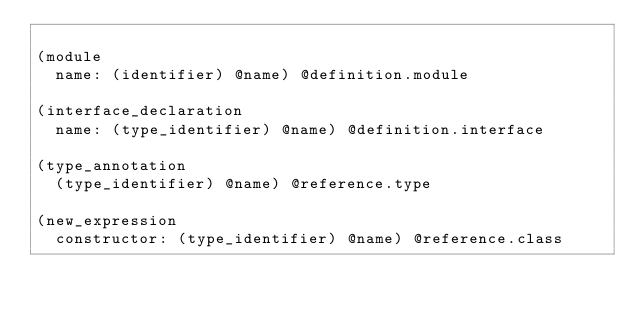<code> <loc_0><loc_0><loc_500><loc_500><_Scheme_>
(module
  name: (identifier) @name) @definition.module

(interface_declaration
  name: (type_identifier) @name) @definition.interface

(type_annotation
  (type_identifier) @name) @reference.type

(new_expression
  constructor: (type_identifier) @name) @reference.class
</code> 